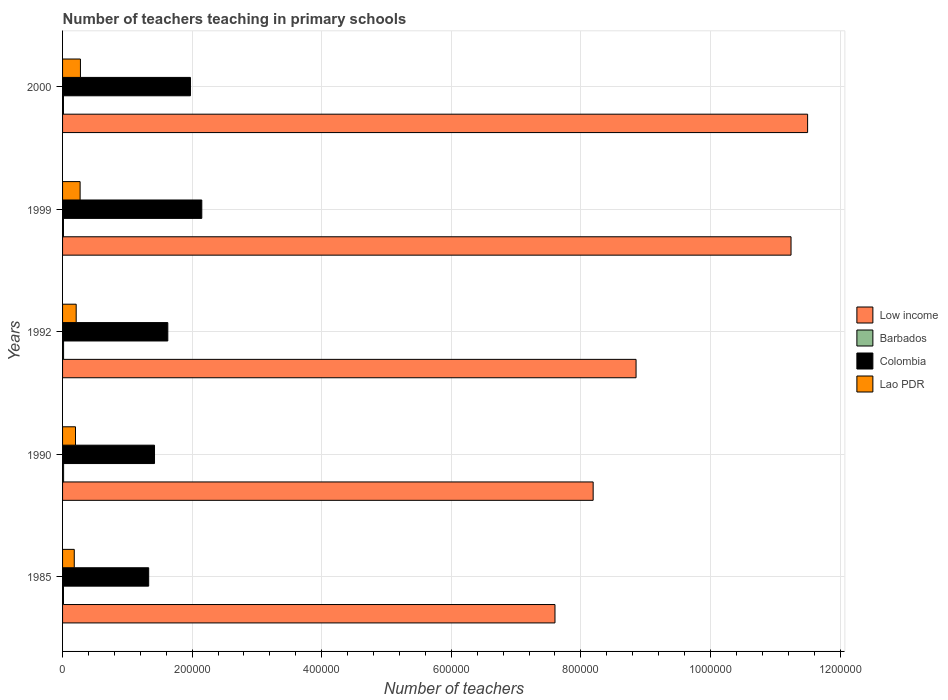How many groups of bars are there?
Offer a terse response. 5. Are the number of bars per tick equal to the number of legend labels?
Make the answer very short. Yes. Are the number of bars on each tick of the Y-axis equal?
Keep it short and to the point. Yes. How many bars are there on the 1st tick from the bottom?
Offer a very short reply. 4. What is the label of the 1st group of bars from the top?
Keep it short and to the point. 2000. In how many cases, is the number of bars for a given year not equal to the number of legend labels?
Make the answer very short. 0. What is the number of teachers teaching in primary schools in Low income in 2000?
Offer a very short reply. 1.15e+06. Across all years, what is the maximum number of teachers teaching in primary schools in Barbados?
Your answer should be very brief. 1602. Across all years, what is the minimum number of teachers teaching in primary schools in Colombia?
Give a very brief answer. 1.33e+05. In which year was the number of teachers teaching in primary schools in Lao PDR maximum?
Keep it short and to the point. 2000. What is the total number of teachers teaching in primary schools in Lao PDR in the graph?
Provide a succinct answer. 1.14e+05. What is the difference between the number of teachers teaching in primary schools in Colombia in 1990 and that in 2000?
Your answer should be compact. -5.54e+04. What is the difference between the number of teachers teaching in primary schools in Low income in 1992 and the number of teachers teaching in primary schools in Colombia in 1999?
Give a very brief answer. 6.70e+05. What is the average number of teachers teaching in primary schools in Barbados per year?
Provide a succinct answer. 1472.8. In the year 2000, what is the difference between the number of teachers teaching in primary schools in Barbados and number of teachers teaching in primary schools in Low income?
Your answer should be compact. -1.15e+06. In how many years, is the number of teachers teaching in primary schools in Low income greater than 880000 ?
Offer a very short reply. 3. What is the ratio of the number of teachers teaching in primary schools in Colombia in 1985 to that in 2000?
Your answer should be very brief. 0.67. What is the difference between the highest and the second highest number of teachers teaching in primary schools in Low income?
Provide a succinct answer. 2.56e+04. What is the difference between the highest and the lowest number of teachers teaching in primary schools in Low income?
Keep it short and to the point. 3.90e+05. In how many years, is the number of teachers teaching in primary schools in Lao PDR greater than the average number of teachers teaching in primary schools in Lao PDR taken over all years?
Offer a terse response. 2. What does the 2nd bar from the top in 1999 represents?
Your response must be concise. Colombia. What does the 2nd bar from the bottom in 2000 represents?
Keep it short and to the point. Barbados. Is it the case that in every year, the sum of the number of teachers teaching in primary schools in Barbados and number of teachers teaching in primary schools in Lao PDR is greater than the number of teachers teaching in primary schools in Low income?
Provide a short and direct response. No. How many bars are there?
Offer a terse response. 20. What is the difference between two consecutive major ticks on the X-axis?
Make the answer very short. 2.00e+05. Where does the legend appear in the graph?
Your response must be concise. Center right. What is the title of the graph?
Make the answer very short. Number of teachers teaching in primary schools. What is the label or title of the X-axis?
Make the answer very short. Number of teachers. What is the label or title of the Y-axis?
Your answer should be very brief. Years. What is the Number of teachers of Low income in 1985?
Keep it short and to the point. 7.60e+05. What is the Number of teachers in Barbados in 1985?
Your answer should be compact. 1421. What is the Number of teachers in Colombia in 1985?
Make the answer very short. 1.33e+05. What is the Number of teachers in Lao PDR in 1985?
Provide a succinct answer. 1.81e+04. What is the Number of teachers in Low income in 1990?
Your response must be concise. 8.19e+05. What is the Number of teachers of Barbados in 1990?
Offer a terse response. 1602. What is the Number of teachers in Colombia in 1990?
Offer a very short reply. 1.42e+05. What is the Number of teachers in Lao PDR in 1990?
Offer a very short reply. 2.00e+04. What is the Number of teachers of Low income in 1992?
Offer a very short reply. 8.85e+05. What is the Number of teachers of Barbados in 1992?
Your response must be concise. 1553. What is the Number of teachers in Colombia in 1992?
Your answer should be very brief. 1.62e+05. What is the Number of teachers of Lao PDR in 1992?
Give a very brief answer. 2.10e+04. What is the Number of teachers in Low income in 1999?
Your answer should be very brief. 1.12e+06. What is the Number of teachers in Barbados in 1999?
Make the answer very short. 1395. What is the Number of teachers in Colombia in 1999?
Make the answer very short. 2.15e+05. What is the Number of teachers in Lao PDR in 1999?
Keep it short and to the point. 2.71e+04. What is the Number of teachers in Low income in 2000?
Provide a short and direct response. 1.15e+06. What is the Number of teachers in Barbados in 2000?
Give a very brief answer. 1393. What is the Number of teachers in Colombia in 2000?
Provide a short and direct response. 1.97e+05. What is the Number of teachers of Lao PDR in 2000?
Offer a terse response. 2.76e+04. Across all years, what is the maximum Number of teachers in Low income?
Your answer should be very brief. 1.15e+06. Across all years, what is the maximum Number of teachers of Barbados?
Your answer should be very brief. 1602. Across all years, what is the maximum Number of teachers in Colombia?
Your response must be concise. 2.15e+05. Across all years, what is the maximum Number of teachers in Lao PDR?
Offer a terse response. 2.76e+04. Across all years, what is the minimum Number of teachers in Low income?
Provide a succinct answer. 7.60e+05. Across all years, what is the minimum Number of teachers in Barbados?
Your answer should be very brief. 1393. Across all years, what is the minimum Number of teachers of Colombia?
Offer a very short reply. 1.33e+05. Across all years, what is the minimum Number of teachers in Lao PDR?
Your response must be concise. 1.81e+04. What is the total Number of teachers in Low income in the graph?
Ensure brevity in your answer.  4.74e+06. What is the total Number of teachers in Barbados in the graph?
Keep it short and to the point. 7364. What is the total Number of teachers in Colombia in the graph?
Your answer should be very brief. 8.50e+05. What is the total Number of teachers in Lao PDR in the graph?
Keep it short and to the point. 1.14e+05. What is the difference between the Number of teachers in Low income in 1985 and that in 1990?
Your answer should be compact. -5.89e+04. What is the difference between the Number of teachers of Barbados in 1985 and that in 1990?
Provide a short and direct response. -181. What is the difference between the Number of teachers in Colombia in 1985 and that in 1990?
Your response must be concise. -8996. What is the difference between the Number of teachers of Lao PDR in 1985 and that in 1990?
Give a very brief answer. -1900. What is the difference between the Number of teachers of Low income in 1985 and that in 1992?
Provide a short and direct response. -1.25e+05. What is the difference between the Number of teachers of Barbados in 1985 and that in 1992?
Offer a very short reply. -132. What is the difference between the Number of teachers of Colombia in 1985 and that in 1992?
Provide a succinct answer. -2.95e+04. What is the difference between the Number of teachers of Lao PDR in 1985 and that in 1992?
Offer a very short reply. -2966. What is the difference between the Number of teachers of Low income in 1985 and that in 1999?
Your answer should be very brief. -3.64e+05. What is the difference between the Number of teachers in Barbados in 1985 and that in 1999?
Give a very brief answer. 26. What is the difference between the Number of teachers in Colombia in 1985 and that in 1999?
Your response must be concise. -8.20e+04. What is the difference between the Number of teachers in Lao PDR in 1985 and that in 1999?
Your answer should be very brief. -9013. What is the difference between the Number of teachers in Low income in 1985 and that in 2000?
Provide a short and direct response. -3.90e+05. What is the difference between the Number of teachers of Colombia in 1985 and that in 2000?
Offer a very short reply. -6.44e+04. What is the difference between the Number of teachers in Lao PDR in 1985 and that in 2000?
Ensure brevity in your answer.  -9522. What is the difference between the Number of teachers of Low income in 1990 and that in 1992?
Provide a succinct answer. -6.62e+04. What is the difference between the Number of teachers of Colombia in 1990 and that in 1992?
Your answer should be very brief. -2.05e+04. What is the difference between the Number of teachers in Lao PDR in 1990 and that in 1992?
Provide a short and direct response. -1066. What is the difference between the Number of teachers in Low income in 1990 and that in 1999?
Give a very brief answer. -3.05e+05. What is the difference between the Number of teachers of Barbados in 1990 and that in 1999?
Make the answer very short. 207. What is the difference between the Number of teachers of Colombia in 1990 and that in 1999?
Provide a succinct answer. -7.30e+04. What is the difference between the Number of teachers of Lao PDR in 1990 and that in 1999?
Your response must be concise. -7113. What is the difference between the Number of teachers of Low income in 1990 and that in 2000?
Your answer should be compact. -3.31e+05. What is the difference between the Number of teachers of Barbados in 1990 and that in 2000?
Your answer should be very brief. 209. What is the difference between the Number of teachers in Colombia in 1990 and that in 2000?
Provide a short and direct response. -5.54e+04. What is the difference between the Number of teachers of Lao PDR in 1990 and that in 2000?
Your response must be concise. -7622. What is the difference between the Number of teachers in Low income in 1992 and that in 1999?
Your response must be concise. -2.39e+05. What is the difference between the Number of teachers of Barbados in 1992 and that in 1999?
Ensure brevity in your answer.  158. What is the difference between the Number of teachers of Colombia in 1992 and that in 1999?
Your response must be concise. -5.25e+04. What is the difference between the Number of teachers in Lao PDR in 1992 and that in 1999?
Offer a terse response. -6047. What is the difference between the Number of teachers of Low income in 1992 and that in 2000?
Offer a very short reply. -2.65e+05. What is the difference between the Number of teachers in Barbados in 1992 and that in 2000?
Your response must be concise. 160. What is the difference between the Number of teachers of Colombia in 1992 and that in 2000?
Provide a succinct answer. -3.49e+04. What is the difference between the Number of teachers in Lao PDR in 1992 and that in 2000?
Offer a very short reply. -6556. What is the difference between the Number of teachers in Low income in 1999 and that in 2000?
Give a very brief answer. -2.56e+04. What is the difference between the Number of teachers of Barbados in 1999 and that in 2000?
Your response must be concise. 2. What is the difference between the Number of teachers of Colombia in 1999 and that in 2000?
Make the answer very short. 1.75e+04. What is the difference between the Number of teachers of Lao PDR in 1999 and that in 2000?
Make the answer very short. -509. What is the difference between the Number of teachers of Low income in 1985 and the Number of teachers of Barbados in 1990?
Offer a terse response. 7.58e+05. What is the difference between the Number of teachers in Low income in 1985 and the Number of teachers in Colombia in 1990?
Give a very brief answer. 6.18e+05. What is the difference between the Number of teachers in Low income in 1985 and the Number of teachers in Lao PDR in 1990?
Offer a terse response. 7.40e+05. What is the difference between the Number of teachers of Barbados in 1985 and the Number of teachers of Colombia in 1990?
Provide a succinct answer. -1.41e+05. What is the difference between the Number of teachers of Barbados in 1985 and the Number of teachers of Lao PDR in 1990?
Provide a short and direct response. -1.85e+04. What is the difference between the Number of teachers of Colombia in 1985 and the Number of teachers of Lao PDR in 1990?
Provide a succinct answer. 1.13e+05. What is the difference between the Number of teachers in Low income in 1985 and the Number of teachers in Barbados in 1992?
Offer a terse response. 7.58e+05. What is the difference between the Number of teachers of Low income in 1985 and the Number of teachers of Colombia in 1992?
Your answer should be very brief. 5.98e+05. What is the difference between the Number of teachers of Low income in 1985 and the Number of teachers of Lao PDR in 1992?
Your answer should be compact. 7.39e+05. What is the difference between the Number of teachers in Barbados in 1985 and the Number of teachers in Colombia in 1992?
Give a very brief answer. -1.61e+05. What is the difference between the Number of teachers in Barbados in 1985 and the Number of teachers in Lao PDR in 1992?
Ensure brevity in your answer.  -1.96e+04. What is the difference between the Number of teachers of Colombia in 1985 and the Number of teachers of Lao PDR in 1992?
Make the answer very short. 1.12e+05. What is the difference between the Number of teachers in Low income in 1985 and the Number of teachers in Barbados in 1999?
Your answer should be compact. 7.59e+05. What is the difference between the Number of teachers of Low income in 1985 and the Number of teachers of Colombia in 1999?
Offer a terse response. 5.45e+05. What is the difference between the Number of teachers of Low income in 1985 and the Number of teachers of Lao PDR in 1999?
Provide a succinct answer. 7.33e+05. What is the difference between the Number of teachers in Barbados in 1985 and the Number of teachers in Colombia in 1999?
Ensure brevity in your answer.  -2.13e+05. What is the difference between the Number of teachers of Barbados in 1985 and the Number of teachers of Lao PDR in 1999?
Give a very brief answer. -2.57e+04. What is the difference between the Number of teachers in Colombia in 1985 and the Number of teachers in Lao PDR in 1999?
Keep it short and to the point. 1.06e+05. What is the difference between the Number of teachers in Low income in 1985 and the Number of teachers in Barbados in 2000?
Your answer should be very brief. 7.59e+05. What is the difference between the Number of teachers of Low income in 1985 and the Number of teachers of Colombia in 2000?
Offer a terse response. 5.63e+05. What is the difference between the Number of teachers in Low income in 1985 and the Number of teachers in Lao PDR in 2000?
Provide a succinct answer. 7.32e+05. What is the difference between the Number of teachers in Barbados in 1985 and the Number of teachers in Colombia in 2000?
Provide a short and direct response. -1.96e+05. What is the difference between the Number of teachers of Barbados in 1985 and the Number of teachers of Lao PDR in 2000?
Provide a short and direct response. -2.62e+04. What is the difference between the Number of teachers of Colombia in 1985 and the Number of teachers of Lao PDR in 2000?
Keep it short and to the point. 1.05e+05. What is the difference between the Number of teachers of Low income in 1990 and the Number of teachers of Barbados in 1992?
Provide a succinct answer. 8.17e+05. What is the difference between the Number of teachers in Low income in 1990 and the Number of teachers in Colombia in 1992?
Keep it short and to the point. 6.57e+05. What is the difference between the Number of teachers in Low income in 1990 and the Number of teachers in Lao PDR in 1992?
Offer a very short reply. 7.98e+05. What is the difference between the Number of teachers of Barbados in 1990 and the Number of teachers of Colombia in 1992?
Your answer should be compact. -1.61e+05. What is the difference between the Number of teachers in Barbados in 1990 and the Number of teachers in Lao PDR in 1992?
Make the answer very short. -1.94e+04. What is the difference between the Number of teachers of Colombia in 1990 and the Number of teachers of Lao PDR in 1992?
Offer a very short reply. 1.21e+05. What is the difference between the Number of teachers in Low income in 1990 and the Number of teachers in Barbados in 1999?
Offer a terse response. 8.18e+05. What is the difference between the Number of teachers in Low income in 1990 and the Number of teachers in Colombia in 1999?
Make the answer very short. 6.04e+05. What is the difference between the Number of teachers of Low income in 1990 and the Number of teachers of Lao PDR in 1999?
Your answer should be very brief. 7.92e+05. What is the difference between the Number of teachers of Barbados in 1990 and the Number of teachers of Colombia in 1999?
Your response must be concise. -2.13e+05. What is the difference between the Number of teachers of Barbados in 1990 and the Number of teachers of Lao PDR in 1999?
Your answer should be very brief. -2.55e+04. What is the difference between the Number of teachers of Colombia in 1990 and the Number of teachers of Lao PDR in 1999?
Provide a short and direct response. 1.15e+05. What is the difference between the Number of teachers in Low income in 1990 and the Number of teachers in Barbados in 2000?
Provide a succinct answer. 8.18e+05. What is the difference between the Number of teachers in Low income in 1990 and the Number of teachers in Colombia in 2000?
Your answer should be compact. 6.22e+05. What is the difference between the Number of teachers of Low income in 1990 and the Number of teachers of Lao PDR in 2000?
Provide a succinct answer. 7.91e+05. What is the difference between the Number of teachers of Barbados in 1990 and the Number of teachers of Colombia in 2000?
Keep it short and to the point. -1.96e+05. What is the difference between the Number of teachers of Barbados in 1990 and the Number of teachers of Lao PDR in 2000?
Your answer should be compact. -2.60e+04. What is the difference between the Number of teachers in Colombia in 1990 and the Number of teachers in Lao PDR in 2000?
Your response must be concise. 1.14e+05. What is the difference between the Number of teachers in Low income in 1992 and the Number of teachers in Barbados in 1999?
Your response must be concise. 8.84e+05. What is the difference between the Number of teachers in Low income in 1992 and the Number of teachers in Colombia in 1999?
Give a very brief answer. 6.70e+05. What is the difference between the Number of teachers in Low income in 1992 and the Number of teachers in Lao PDR in 1999?
Keep it short and to the point. 8.58e+05. What is the difference between the Number of teachers in Barbados in 1992 and the Number of teachers in Colombia in 1999?
Offer a very short reply. -2.13e+05. What is the difference between the Number of teachers in Barbados in 1992 and the Number of teachers in Lao PDR in 1999?
Offer a terse response. -2.55e+04. What is the difference between the Number of teachers in Colombia in 1992 and the Number of teachers in Lao PDR in 1999?
Give a very brief answer. 1.35e+05. What is the difference between the Number of teachers of Low income in 1992 and the Number of teachers of Barbados in 2000?
Your response must be concise. 8.84e+05. What is the difference between the Number of teachers in Low income in 1992 and the Number of teachers in Colombia in 2000?
Provide a succinct answer. 6.88e+05. What is the difference between the Number of teachers in Low income in 1992 and the Number of teachers in Lao PDR in 2000?
Provide a succinct answer. 8.58e+05. What is the difference between the Number of teachers of Barbados in 1992 and the Number of teachers of Colombia in 2000?
Provide a succinct answer. -1.96e+05. What is the difference between the Number of teachers in Barbados in 1992 and the Number of teachers in Lao PDR in 2000?
Offer a very short reply. -2.60e+04. What is the difference between the Number of teachers in Colombia in 1992 and the Number of teachers in Lao PDR in 2000?
Keep it short and to the point. 1.35e+05. What is the difference between the Number of teachers in Low income in 1999 and the Number of teachers in Barbados in 2000?
Make the answer very short. 1.12e+06. What is the difference between the Number of teachers in Low income in 1999 and the Number of teachers in Colombia in 2000?
Ensure brevity in your answer.  9.27e+05. What is the difference between the Number of teachers of Low income in 1999 and the Number of teachers of Lao PDR in 2000?
Offer a very short reply. 1.10e+06. What is the difference between the Number of teachers in Barbados in 1999 and the Number of teachers in Colombia in 2000?
Your response must be concise. -1.96e+05. What is the difference between the Number of teachers in Barbados in 1999 and the Number of teachers in Lao PDR in 2000?
Ensure brevity in your answer.  -2.62e+04. What is the difference between the Number of teachers in Colombia in 1999 and the Number of teachers in Lao PDR in 2000?
Provide a short and direct response. 1.87e+05. What is the average Number of teachers of Low income per year?
Keep it short and to the point. 9.48e+05. What is the average Number of teachers of Barbados per year?
Offer a terse response. 1472.8. What is the average Number of teachers in Colombia per year?
Provide a succinct answer. 1.70e+05. What is the average Number of teachers in Lao PDR per year?
Your answer should be compact. 2.28e+04. In the year 1985, what is the difference between the Number of teachers in Low income and Number of teachers in Barbados?
Keep it short and to the point. 7.59e+05. In the year 1985, what is the difference between the Number of teachers in Low income and Number of teachers in Colombia?
Your answer should be very brief. 6.27e+05. In the year 1985, what is the difference between the Number of teachers of Low income and Number of teachers of Lao PDR?
Keep it short and to the point. 7.42e+05. In the year 1985, what is the difference between the Number of teachers of Barbados and Number of teachers of Colombia?
Ensure brevity in your answer.  -1.32e+05. In the year 1985, what is the difference between the Number of teachers in Barbados and Number of teachers in Lao PDR?
Offer a very short reply. -1.66e+04. In the year 1985, what is the difference between the Number of teachers in Colombia and Number of teachers in Lao PDR?
Your response must be concise. 1.15e+05. In the year 1990, what is the difference between the Number of teachers in Low income and Number of teachers in Barbados?
Offer a terse response. 8.17e+05. In the year 1990, what is the difference between the Number of teachers of Low income and Number of teachers of Colombia?
Make the answer very short. 6.77e+05. In the year 1990, what is the difference between the Number of teachers of Low income and Number of teachers of Lao PDR?
Your answer should be compact. 7.99e+05. In the year 1990, what is the difference between the Number of teachers of Barbados and Number of teachers of Colombia?
Ensure brevity in your answer.  -1.40e+05. In the year 1990, what is the difference between the Number of teachers of Barbados and Number of teachers of Lao PDR?
Offer a very short reply. -1.84e+04. In the year 1990, what is the difference between the Number of teachers in Colombia and Number of teachers in Lao PDR?
Give a very brief answer. 1.22e+05. In the year 1992, what is the difference between the Number of teachers in Low income and Number of teachers in Barbados?
Provide a short and direct response. 8.84e+05. In the year 1992, what is the difference between the Number of teachers of Low income and Number of teachers of Colombia?
Provide a short and direct response. 7.23e+05. In the year 1992, what is the difference between the Number of teachers in Low income and Number of teachers in Lao PDR?
Keep it short and to the point. 8.64e+05. In the year 1992, what is the difference between the Number of teachers in Barbados and Number of teachers in Colombia?
Provide a short and direct response. -1.61e+05. In the year 1992, what is the difference between the Number of teachers of Barbados and Number of teachers of Lao PDR?
Your answer should be compact. -1.95e+04. In the year 1992, what is the difference between the Number of teachers of Colombia and Number of teachers of Lao PDR?
Provide a succinct answer. 1.41e+05. In the year 1999, what is the difference between the Number of teachers of Low income and Number of teachers of Barbados?
Give a very brief answer. 1.12e+06. In the year 1999, what is the difference between the Number of teachers of Low income and Number of teachers of Colombia?
Provide a succinct answer. 9.09e+05. In the year 1999, what is the difference between the Number of teachers in Low income and Number of teachers in Lao PDR?
Keep it short and to the point. 1.10e+06. In the year 1999, what is the difference between the Number of teachers in Barbados and Number of teachers in Colombia?
Provide a short and direct response. -2.14e+05. In the year 1999, what is the difference between the Number of teachers of Barbados and Number of teachers of Lao PDR?
Your response must be concise. -2.57e+04. In the year 1999, what is the difference between the Number of teachers in Colombia and Number of teachers in Lao PDR?
Offer a terse response. 1.88e+05. In the year 2000, what is the difference between the Number of teachers in Low income and Number of teachers in Barbados?
Ensure brevity in your answer.  1.15e+06. In the year 2000, what is the difference between the Number of teachers in Low income and Number of teachers in Colombia?
Ensure brevity in your answer.  9.53e+05. In the year 2000, what is the difference between the Number of teachers in Low income and Number of teachers in Lao PDR?
Make the answer very short. 1.12e+06. In the year 2000, what is the difference between the Number of teachers of Barbados and Number of teachers of Colombia?
Ensure brevity in your answer.  -1.96e+05. In the year 2000, what is the difference between the Number of teachers in Barbados and Number of teachers in Lao PDR?
Offer a very short reply. -2.62e+04. In the year 2000, what is the difference between the Number of teachers in Colombia and Number of teachers in Lao PDR?
Provide a short and direct response. 1.70e+05. What is the ratio of the Number of teachers of Low income in 1985 to that in 1990?
Keep it short and to the point. 0.93. What is the ratio of the Number of teachers in Barbados in 1985 to that in 1990?
Your response must be concise. 0.89. What is the ratio of the Number of teachers in Colombia in 1985 to that in 1990?
Make the answer very short. 0.94. What is the ratio of the Number of teachers of Lao PDR in 1985 to that in 1990?
Offer a terse response. 0.9. What is the ratio of the Number of teachers in Low income in 1985 to that in 1992?
Keep it short and to the point. 0.86. What is the ratio of the Number of teachers of Barbados in 1985 to that in 1992?
Provide a short and direct response. 0.92. What is the ratio of the Number of teachers of Colombia in 1985 to that in 1992?
Your answer should be compact. 0.82. What is the ratio of the Number of teachers in Lao PDR in 1985 to that in 1992?
Offer a terse response. 0.86. What is the ratio of the Number of teachers in Low income in 1985 to that in 1999?
Your response must be concise. 0.68. What is the ratio of the Number of teachers in Barbados in 1985 to that in 1999?
Provide a short and direct response. 1.02. What is the ratio of the Number of teachers in Colombia in 1985 to that in 1999?
Your response must be concise. 0.62. What is the ratio of the Number of teachers in Lao PDR in 1985 to that in 1999?
Offer a very short reply. 0.67. What is the ratio of the Number of teachers of Low income in 1985 to that in 2000?
Offer a very short reply. 0.66. What is the ratio of the Number of teachers in Barbados in 1985 to that in 2000?
Your answer should be compact. 1.02. What is the ratio of the Number of teachers in Colombia in 1985 to that in 2000?
Your response must be concise. 0.67. What is the ratio of the Number of teachers in Lao PDR in 1985 to that in 2000?
Ensure brevity in your answer.  0.65. What is the ratio of the Number of teachers in Low income in 1990 to that in 1992?
Your answer should be compact. 0.93. What is the ratio of the Number of teachers in Barbados in 1990 to that in 1992?
Make the answer very short. 1.03. What is the ratio of the Number of teachers in Colombia in 1990 to that in 1992?
Offer a very short reply. 0.87. What is the ratio of the Number of teachers in Lao PDR in 1990 to that in 1992?
Offer a very short reply. 0.95. What is the ratio of the Number of teachers in Low income in 1990 to that in 1999?
Keep it short and to the point. 0.73. What is the ratio of the Number of teachers in Barbados in 1990 to that in 1999?
Provide a succinct answer. 1.15. What is the ratio of the Number of teachers of Colombia in 1990 to that in 1999?
Provide a short and direct response. 0.66. What is the ratio of the Number of teachers in Lao PDR in 1990 to that in 1999?
Keep it short and to the point. 0.74. What is the ratio of the Number of teachers of Low income in 1990 to that in 2000?
Offer a terse response. 0.71. What is the ratio of the Number of teachers in Barbados in 1990 to that in 2000?
Offer a very short reply. 1.15. What is the ratio of the Number of teachers in Colombia in 1990 to that in 2000?
Make the answer very short. 0.72. What is the ratio of the Number of teachers of Lao PDR in 1990 to that in 2000?
Give a very brief answer. 0.72. What is the ratio of the Number of teachers in Low income in 1992 to that in 1999?
Provide a short and direct response. 0.79. What is the ratio of the Number of teachers in Barbados in 1992 to that in 1999?
Keep it short and to the point. 1.11. What is the ratio of the Number of teachers in Colombia in 1992 to that in 1999?
Your answer should be compact. 0.76. What is the ratio of the Number of teachers in Lao PDR in 1992 to that in 1999?
Offer a very short reply. 0.78. What is the ratio of the Number of teachers of Low income in 1992 to that in 2000?
Make the answer very short. 0.77. What is the ratio of the Number of teachers of Barbados in 1992 to that in 2000?
Your answer should be very brief. 1.11. What is the ratio of the Number of teachers in Colombia in 1992 to that in 2000?
Offer a very short reply. 0.82. What is the ratio of the Number of teachers of Lao PDR in 1992 to that in 2000?
Offer a terse response. 0.76. What is the ratio of the Number of teachers in Low income in 1999 to that in 2000?
Your answer should be very brief. 0.98. What is the ratio of the Number of teachers of Colombia in 1999 to that in 2000?
Your response must be concise. 1.09. What is the ratio of the Number of teachers in Lao PDR in 1999 to that in 2000?
Provide a short and direct response. 0.98. What is the difference between the highest and the second highest Number of teachers in Low income?
Give a very brief answer. 2.56e+04. What is the difference between the highest and the second highest Number of teachers in Colombia?
Make the answer very short. 1.75e+04. What is the difference between the highest and the second highest Number of teachers of Lao PDR?
Provide a succinct answer. 509. What is the difference between the highest and the lowest Number of teachers of Low income?
Make the answer very short. 3.90e+05. What is the difference between the highest and the lowest Number of teachers in Barbados?
Your response must be concise. 209. What is the difference between the highest and the lowest Number of teachers in Colombia?
Your response must be concise. 8.20e+04. What is the difference between the highest and the lowest Number of teachers in Lao PDR?
Your response must be concise. 9522. 